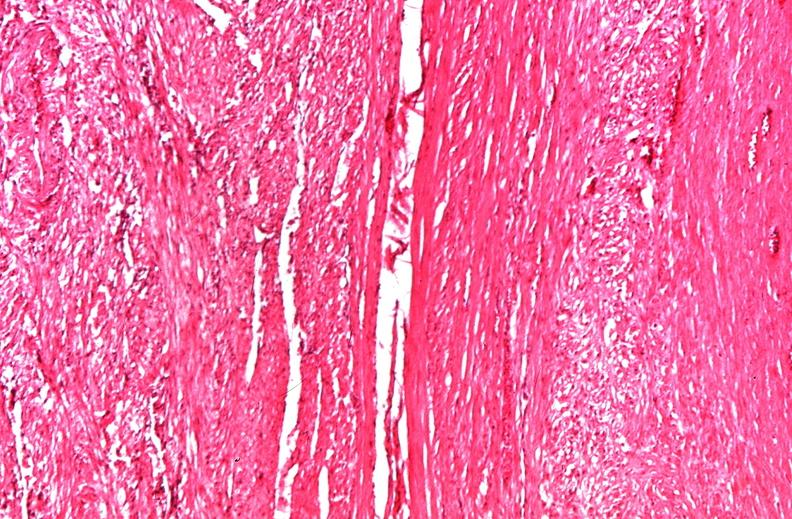where is this from?
Answer the question using a single word or phrase. Female reproductive system 